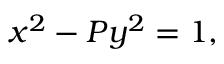<formula> <loc_0><loc_0><loc_500><loc_500>\ x ^ { 2 } - P y ^ { 2 } = 1 ,</formula> 